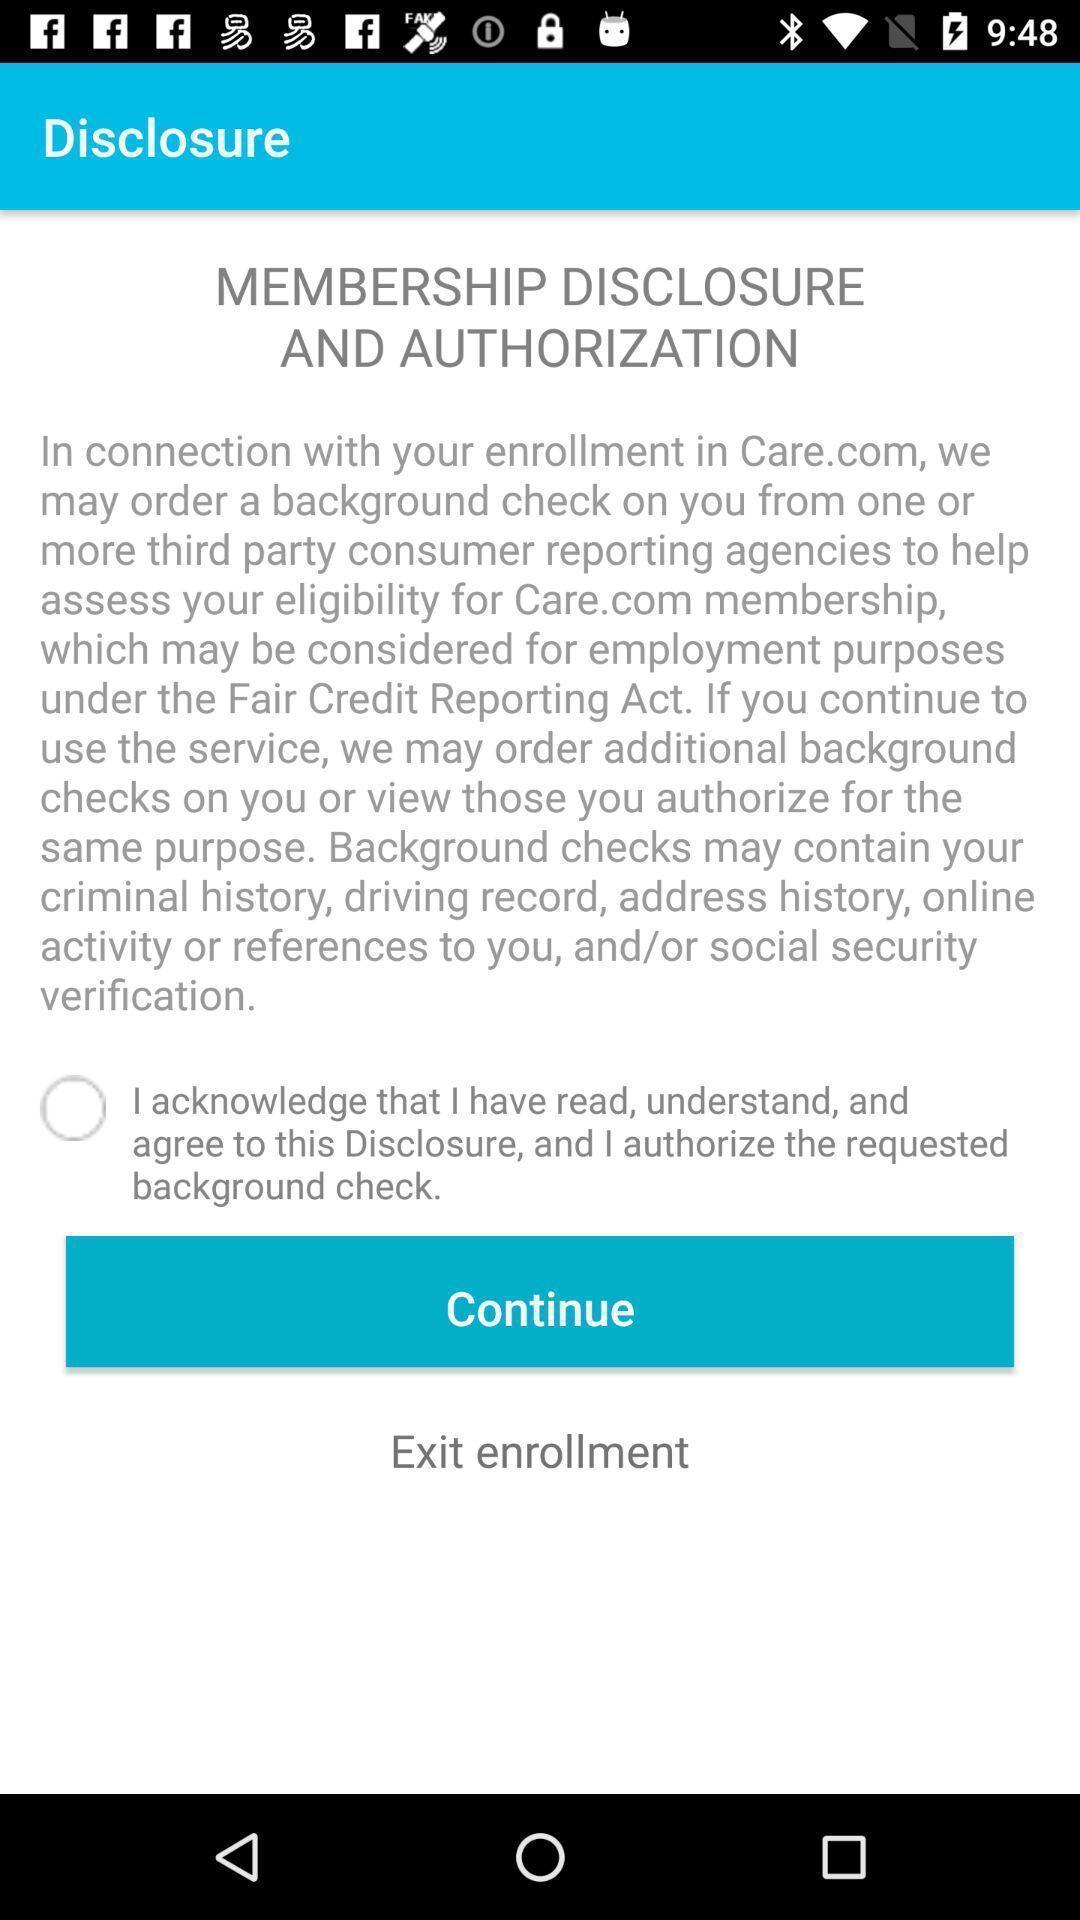Describe this image in words. Page displaying an information with an option. 